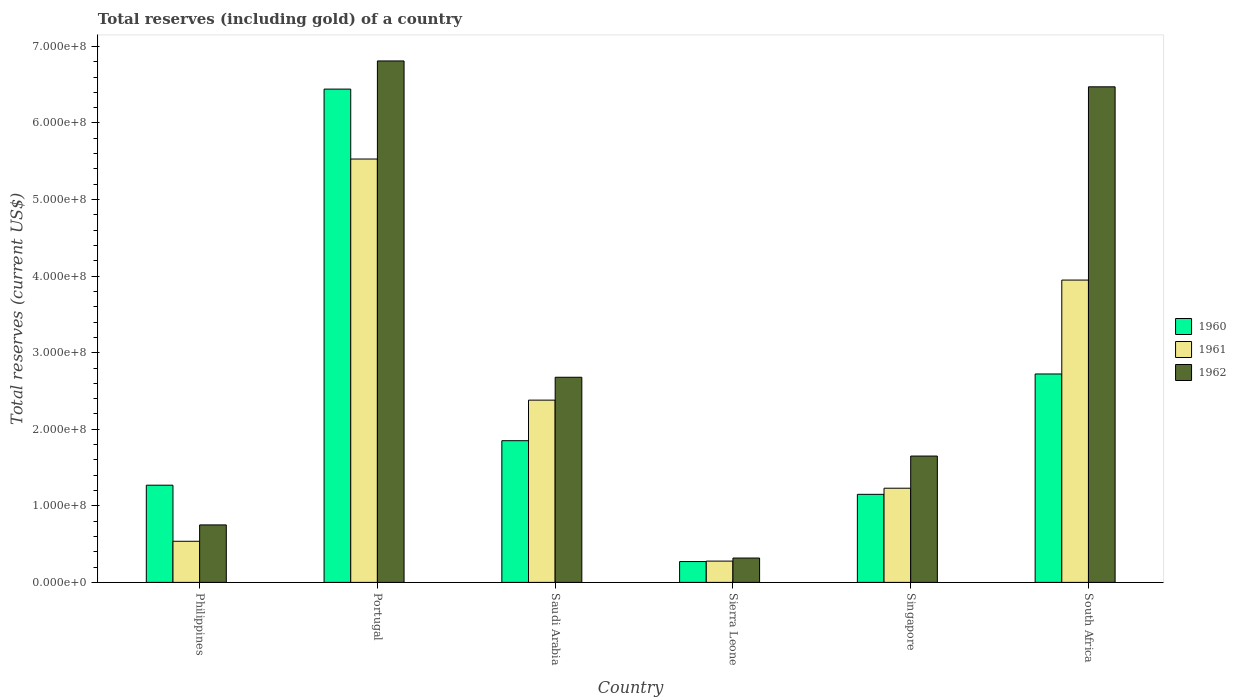How many bars are there on the 5th tick from the left?
Keep it short and to the point. 3. What is the label of the 3rd group of bars from the left?
Give a very brief answer. Saudi Arabia. What is the total reserves (including gold) in 1962 in Saudi Arabia?
Provide a short and direct response. 2.68e+08. Across all countries, what is the maximum total reserves (including gold) in 1960?
Provide a succinct answer. 6.44e+08. Across all countries, what is the minimum total reserves (including gold) in 1962?
Your answer should be very brief. 3.18e+07. In which country was the total reserves (including gold) in 1960 maximum?
Make the answer very short. Portugal. In which country was the total reserves (including gold) in 1961 minimum?
Provide a succinct answer. Sierra Leone. What is the total total reserves (including gold) in 1961 in the graph?
Your answer should be compact. 1.39e+09. What is the difference between the total reserves (including gold) in 1960 in Singapore and that in South Africa?
Offer a terse response. -1.57e+08. What is the difference between the total reserves (including gold) in 1960 in Portugal and the total reserves (including gold) in 1962 in Sierra Leone?
Your response must be concise. 6.12e+08. What is the average total reserves (including gold) in 1961 per country?
Your answer should be compact. 2.32e+08. What is the difference between the total reserves (including gold) of/in 1962 and total reserves (including gold) of/in 1960 in Portugal?
Provide a short and direct response. 3.68e+07. What is the ratio of the total reserves (including gold) in 1962 in Saudi Arabia to that in South Africa?
Provide a short and direct response. 0.41. Is the total reserves (including gold) in 1962 in Philippines less than that in Saudi Arabia?
Offer a terse response. Yes. Is the difference between the total reserves (including gold) in 1962 in Portugal and Saudi Arabia greater than the difference between the total reserves (including gold) in 1960 in Portugal and Saudi Arabia?
Make the answer very short. No. What is the difference between the highest and the second highest total reserves (including gold) in 1961?
Give a very brief answer. -1.58e+08. What is the difference between the highest and the lowest total reserves (including gold) in 1962?
Ensure brevity in your answer.  6.49e+08. What does the 3rd bar from the left in South Africa represents?
Provide a short and direct response. 1962. Is it the case that in every country, the sum of the total reserves (including gold) in 1961 and total reserves (including gold) in 1962 is greater than the total reserves (including gold) in 1960?
Provide a short and direct response. Yes. How many countries are there in the graph?
Your answer should be very brief. 6. Does the graph contain grids?
Offer a terse response. No. Where does the legend appear in the graph?
Keep it short and to the point. Center right. How many legend labels are there?
Your answer should be very brief. 3. How are the legend labels stacked?
Give a very brief answer. Vertical. What is the title of the graph?
Your answer should be very brief. Total reserves (including gold) of a country. What is the label or title of the Y-axis?
Give a very brief answer. Total reserves (current US$). What is the Total reserves (current US$) of 1960 in Philippines?
Offer a terse response. 1.27e+08. What is the Total reserves (current US$) in 1961 in Philippines?
Offer a terse response. 5.37e+07. What is the Total reserves (current US$) in 1962 in Philippines?
Offer a terse response. 7.51e+07. What is the Total reserves (current US$) of 1960 in Portugal?
Provide a short and direct response. 6.44e+08. What is the Total reserves (current US$) in 1961 in Portugal?
Keep it short and to the point. 5.53e+08. What is the Total reserves (current US$) of 1962 in Portugal?
Ensure brevity in your answer.  6.81e+08. What is the Total reserves (current US$) in 1960 in Saudi Arabia?
Your answer should be very brief. 1.85e+08. What is the Total reserves (current US$) in 1961 in Saudi Arabia?
Make the answer very short. 2.38e+08. What is the Total reserves (current US$) in 1962 in Saudi Arabia?
Offer a terse response. 2.68e+08. What is the Total reserves (current US$) of 1960 in Sierra Leone?
Offer a very short reply. 2.72e+07. What is the Total reserves (current US$) of 1961 in Sierra Leone?
Offer a terse response. 2.78e+07. What is the Total reserves (current US$) in 1962 in Sierra Leone?
Your response must be concise. 3.18e+07. What is the Total reserves (current US$) in 1960 in Singapore?
Your answer should be very brief. 1.15e+08. What is the Total reserves (current US$) in 1961 in Singapore?
Offer a terse response. 1.23e+08. What is the Total reserves (current US$) of 1962 in Singapore?
Provide a succinct answer. 1.65e+08. What is the Total reserves (current US$) in 1960 in South Africa?
Give a very brief answer. 2.72e+08. What is the Total reserves (current US$) in 1961 in South Africa?
Your answer should be very brief. 3.95e+08. What is the Total reserves (current US$) of 1962 in South Africa?
Offer a very short reply. 6.47e+08. Across all countries, what is the maximum Total reserves (current US$) in 1960?
Your answer should be very brief. 6.44e+08. Across all countries, what is the maximum Total reserves (current US$) of 1961?
Offer a terse response. 5.53e+08. Across all countries, what is the maximum Total reserves (current US$) of 1962?
Ensure brevity in your answer.  6.81e+08. Across all countries, what is the minimum Total reserves (current US$) of 1960?
Offer a terse response. 2.72e+07. Across all countries, what is the minimum Total reserves (current US$) in 1961?
Offer a terse response. 2.78e+07. Across all countries, what is the minimum Total reserves (current US$) of 1962?
Make the answer very short. 3.18e+07. What is the total Total reserves (current US$) of 1960 in the graph?
Ensure brevity in your answer.  1.37e+09. What is the total Total reserves (current US$) in 1961 in the graph?
Offer a terse response. 1.39e+09. What is the total Total reserves (current US$) in 1962 in the graph?
Ensure brevity in your answer.  1.87e+09. What is the difference between the Total reserves (current US$) in 1960 in Philippines and that in Portugal?
Ensure brevity in your answer.  -5.17e+08. What is the difference between the Total reserves (current US$) of 1961 in Philippines and that in Portugal?
Your answer should be compact. -4.99e+08. What is the difference between the Total reserves (current US$) in 1962 in Philippines and that in Portugal?
Give a very brief answer. -6.06e+08. What is the difference between the Total reserves (current US$) in 1960 in Philippines and that in Saudi Arabia?
Provide a succinct answer. -5.81e+07. What is the difference between the Total reserves (current US$) in 1961 in Philippines and that in Saudi Arabia?
Your answer should be compact. -1.84e+08. What is the difference between the Total reserves (current US$) in 1962 in Philippines and that in Saudi Arabia?
Keep it short and to the point. -1.93e+08. What is the difference between the Total reserves (current US$) in 1960 in Philippines and that in Sierra Leone?
Your response must be concise. 9.97e+07. What is the difference between the Total reserves (current US$) of 1961 in Philippines and that in Sierra Leone?
Make the answer very short. 2.59e+07. What is the difference between the Total reserves (current US$) of 1962 in Philippines and that in Sierra Leone?
Provide a short and direct response. 4.33e+07. What is the difference between the Total reserves (current US$) in 1960 in Philippines and that in Singapore?
Give a very brief answer. 1.19e+07. What is the difference between the Total reserves (current US$) of 1961 in Philippines and that in Singapore?
Offer a terse response. -6.93e+07. What is the difference between the Total reserves (current US$) of 1962 in Philippines and that in Singapore?
Make the answer very short. -8.99e+07. What is the difference between the Total reserves (current US$) in 1960 in Philippines and that in South Africa?
Offer a terse response. -1.45e+08. What is the difference between the Total reserves (current US$) in 1961 in Philippines and that in South Africa?
Keep it short and to the point. -3.41e+08. What is the difference between the Total reserves (current US$) in 1962 in Philippines and that in South Africa?
Your answer should be very brief. -5.72e+08. What is the difference between the Total reserves (current US$) in 1960 in Portugal and that in Saudi Arabia?
Keep it short and to the point. 4.59e+08. What is the difference between the Total reserves (current US$) in 1961 in Portugal and that in Saudi Arabia?
Provide a short and direct response. 3.15e+08. What is the difference between the Total reserves (current US$) of 1962 in Portugal and that in Saudi Arabia?
Provide a succinct answer. 4.13e+08. What is the difference between the Total reserves (current US$) of 1960 in Portugal and that in Sierra Leone?
Provide a succinct answer. 6.17e+08. What is the difference between the Total reserves (current US$) of 1961 in Portugal and that in Sierra Leone?
Keep it short and to the point. 5.25e+08. What is the difference between the Total reserves (current US$) in 1962 in Portugal and that in Sierra Leone?
Make the answer very short. 6.49e+08. What is the difference between the Total reserves (current US$) of 1960 in Portugal and that in Singapore?
Provide a short and direct response. 5.29e+08. What is the difference between the Total reserves (current US$) of 1961 in Portugal and that in Singapore?
Provide a short and direct response. 4.30e+08. What is the difference between the Total reserves (current US$) in 1962 in Portugal and that in Singapore?
Make the answer very short. 5.16e+08. What is the difference between the Total reserves (current US$) of 1960 in Portugal and that in South Africa?
Your response must be concise. 3.72e+08. What is the difference between the Total reserves (current US$) of 1961 in Portugal and that in South Africa?
Offer a very short reply. 1.58e+08. What is the difference between the Total reserves (current US$) of 1962 in Portugal and that in South Africa?
Your answer should be compact. 3.38e+07. What is the difference between the Total reserves (current US$) of 1960 in Saudi Arabia and that in Sierra Leone?
Make the answer very short. 1.58e+08. What is the difference between the Total reserves (current US$) in 1961 in Saudi Arabia and that in Sierra Leone?
Offer a very short reply. 2.10e+08. What is the difference between the Total reserves (current US$) of 1962 in Saudi Arabia and that in Sierra Leone?
Your answer should be compact. 2.36e+08. What is the difference between the Total reserves (current US$) of 1960 in Saudi Arabia and that in Singapore?
Keep it short and to the point. 7.01e+07. What is the difference between the Total reserves (current US$) in 1961 in Saudi Arabia and that in Singapore?
Your answer should be very brief. 1.15e+08. What is the difference between the Total reserves (current US$) in 1962 in Saudi Arabia and that in Singapore?
Keep it short and to the point. 1.03e+08. What is the difference between the Total reserves (current US$) of 1960 in Saudi Arabia and that in South Africa?
Provide a short and direct response. -8.71e+07. What is the difference between the Total reserves (current US$) of 1961 in Saudi Arabia and that in South Africa?
Keep it short and to the point. -1.57e+08. What is the difference between the Total reserves (current US$) in 1962 in Saudi Arabia and that in South Africa?
Your response must be concise. -3.79e+08. What is the difference between the Total reserves (current US$) in 1960 in Sierra Leone and that in Singapore?
Your answer should be compact. -8.78e+07. What is the difference between the Total reserves (current US$) of 1961 in Sierra Leone and that in Singapore?
Offer a terse response. -9.52e+07. What is the difference between the Total reserves (current US$) of 1962 in Sierra Leone and that in Singapore?
Provide a succinct answer. -1.33e+08. What is the difference between the Total reserves (current US$) in 1960 in Sierra Leone and that in South Africa?
Offer a terse response. -2.45e+08. What is the difference between the Total reserves (current US$) of 1961 in Sierra Leone and that in South Africa?
Offer a terse response. -3.67e+08. What is the difference between the Total reserves (current US$) of 1962 in Sierra Leone and that in South Africa?
Your response must be concise. -6.15e+08. What is the difference between the Total reserves (current US$) in 1960 in Singapore and that in South Africa?
Your answer should be compact. -1.57e+08. What is the difference between the Total reserves (current US$) in 1961 in Singapore and that in South Africa?
Ensure brevity in your answer.  -2.72e+08. What is the difference between the Total reserves (current US$) of 1962 in Singapore and that in South Africa?
Ensure brevity in your answer.  -4.82e+08. What is the difference between the Total reserves (current US$) of 1960 in Philippines and the Total reserves (current US$) of 1961 in Portugal?
Keep it short and to the point. -4.26e+08. What is the difference between the Total reserves (current US$) of 1960 in Philippines and the Total reserves (current US$) of 1962 in Portugal?
Offer a terse response. -5.54e+08. What is the difference between the Total reserves (current US$) of 1961 in Philippines and the Total reserves (current US$) of 1962 in Portugal?
Provide a short and direct response. -6.27e+08. What is the difference between the Total reserves (current US$) in 1960 in Philippines and the Total reserves (current US$) in 1961 in Saudi Arabia?
Your answer should be compact. -1.11e+08. What is the difference between the Total reserves (current US$) of 1960 in Philippines and the Total reserves (current US$) of 1962 in Saudi Arabia?
Ensure brevity in your answer.  -1.41e+08. What is the difference between the Total reserves (current US$) of 1961 in Philippines and the Total reserves (current US$) of 1962 in Saudi Arabia?
Offer a terse response. -2.14e+08. What is the difference between the Total reserves (current US$) of 1960 in Philippines and the Total reserves (current US$) of 1961 in Sierra Leone?
Your answer should be compact. 9.91e+07. What is the difference between the Total reserves (current US$) in 1960 in Philippines and the Total reserves (current US$) in 1962 in Sierra Leone?
Give a very brief answer. 9.51e+07. What is the difference between the Total reserves (current US$) in 1961 in Philippines and the Total reserves (current US$) in 1962 in Sierra Leone?
Provide a succinct answer. 2.19e+07. What is the difference between the Total reserves (current US$) of 1960 in Philippines and the Total reserves (current US$) of 1961 in Singapore?
Ensure brevity in your answer.  3.94e+06. What is the difference between the Total reserves (current US$) of 1960 in Philippines and the Total reserves (current US$) of 1962 in Singapore?
Offer a terse response. -3.81e+07. What is the difference between the Total reserves (current US$) in 1961 in Philippines and the Total reserves (current US$) in 1962 in Singapore?
Your answer should be very brief. -1.11e+08. What is the difference between the Total reserves (current US$) in 1960 in Philippines and the Total reserves (current US$) in 1961 in South Africa?
Your response must be concise. -2.68e+08. What is the difference between the Total reserves (current US$) in 1960 in Philippines and the Total reserves (current US$) in 1962 in South Africa?
Ensure brevity in your answer.  -5.20e+08. What is the difference between the Total reserves (current US$) in 1961 in Philippines and the Total reserves (current US$) in 1962 in South Africa?
Provide a short and direct response. -5.94e+08. What is the difference between the Total reserves (current US$) in 1960 in Portugal and the Total reserves (current US$) in 1961 in Saudi Arabia?
Your response must be concise. 4.06e+08. What is the difference between the Total reserves (current US$) in 1960 in Portugal and the Total reserves (current US$) in 1962 in Saudi Arabia?
Ensure brevity in your answer.  3.76e+08. What is the difference between the Total reserves (current US$) of 1961 in Portugal and the Total reserves (current US$) of 1962 in Saudi Arabia?
Make the answer very short. 2.85e+08. What is the difference between the Total reserves (current US$) of 1960 in Portugal and the Total reserves (current US$) of 1961 in Sierra Leone?
Provide a succinct answer. 6.16e+08. What is the difference between the Total reserves (current US$) of 1960 in Portugal and the Total reserves (current US$) of 1962 in Sierra Leone?
Your answer should be compact. 6.12e+08. What is the difference between the Total reserves (current US$) in 1961 in Portugal and the Total reserves (current US$) in 1962 in Sierra Leone?
Offer a very short reply. 5.21e+08. What is the difference between the Total reserves (current US$) of 1960 in Portugal and the Total reserves (current US$) of 1961 in Singapore?
Your answer should be compact. 5.21e+08. What is the difference between the Total reserves (current US$) of 1960 in Portugal and the Total reserves (current US$) of 1962 in Singapore?
Ensure brevity in your answer.  4.79e+08. What is the difference between the Total reserves (current US$) in 1961 in Portugal and the Total reserves (current US$) in 1962 in Singapore?
Your answer should be compact. 3.88e+08. What is the difference between the Total reserves (current US$) of 1960 in Portugal and the Total reserves (current US$) of 1961 in South Africa?
Give a very brief answer. 2.49e+08. What is the difference between the Total reserves (current US$) of 1960 in Portugal and the Total reserves (current US$) of 1962 in South Africa?
Your answer should be very brief. -2.97e+06. What is the difference between the Total reserves (current US$) of 1961 in Portugal and the Total reserves (current US$) of 1962 in South Africa?
Offer a very short reply. -9.43e+07. What is the difference between the Total reserves (current US$) in 1960 in Saudi Arabia and the Total reserves (current US$) in 1961 in Sierra Leone?
Provide a short and direct response. 1.57e+08. What is the difference between the Total reserves (current US$) of 1960 in Saudi Arabia and the Total reserves (current US$) of 1962 in Sierra Leone?
Your answer should be very brief. 1.53e+08. What is the difference between the Total reserves (current US$) in 1961 in Saudi Arabia and the Total reserves (current US$) in 1962 in Sierra Leone?
Ensure brevity in your answer.  2.06e+08. What is the difference between the Total reserves (current US$) of 1960 in Saudi Arabia and the Total reserves (current US$) of 1961 in Singapore?
Ensure brevity in your answer.  6.21e+07. What is the difference between the Total reserves (current US$) in 1960 in Saudi Arabia and the Total reserves (current US$) in 1962 in Singapore?
Offer a terse response. 2.01e+07. What is the difference between the Total reserves (current US$) in 1961 in Saudi Arabia and the Total reserves (current US$) in 1962 in Singapore?
Give a very brief answer. 7.30e+07. What is the difference between the Total reserves (current US$) in 1960 in Saudi Arabia and the Total reserves (current US$) in 1961 in South Africa?
Offer a terse response. -2.10e+08. What is the difference between the Total reserves (current US$) of 1960 in Saudi Arabia and the Total reserves (current US$) of 1962 in South Africa?
Keep it short and to the point. -4.62e+08. What is the difference between the Total reserves (current US$) in 1961 in Saudi Arabia and the Total reserves (current US$) in 1962 in South Africa?
Give a very brief answer. -4.09e+08. What is the difference between the Total reserves (current US$) of 1960 in Sierra Leone and the Total reserves (current US$) of 1961 in Singapore?
Provide a succinct answer. -9.58e+07. What is the difference between the Total reserves (current US$) in 1960 in Sierra Leone and the Total reserves (current US$) in 1962 in Singapore?
Keep it short and to the point. -1.38e+08. What is the difference between the Total reserves (current US$) in 1961 in Sierra Leone and the Total reserves (current US$) in 1962 in Singapore?
Provide a short and direct response. -1.37e+08. What is the difference between the Total reserves (current US$) of 1960 in Sierra Leone and the Total reserves (current US$) of 1961 in South Africa?
Provide a short and direct response. -3.68e+08. What is the difference between the Total reserves (current US$) in 1960 in Sierra Leone and the Total reserves (current US$) in 1962 in South Africa?
Offer a terse response. -6.20e+08. What is the difference between the Total reserves (current US$) in 1961 in Sierra Leone and the Total reserves (current US$) in 1962 in South Africa?
Make the answer very short. -6.19e+08. What is the difference between the Total reserves (current US$) of 1960 in Singapore and the Total reserves (current US$) of 1961 in South Africa?
Your response must be concise. -2.80e+08. What is the difference between the Total reserves (current US$) of 1960 in Singapore and the Total reserves (current US$) of 1962 in South Africa?
Your answer should be very brief. -5.32e+08. What is the difference between the Total reserves (current US$) of 1961 in Singapore and the Total reserves (current US$) of 1962 in South Africa?
Make the answer very short. -5.24e+08. What is the average Total reserves (current US$) in 1960 per country?
Provide a short and direct response. 2.28e+08. What is the average Total reserves (current US$) in 1961 per country?
Your response must be concise. 2.32e+08. What is the average Total reserves (current US$) of 1962 per country?
Provide a short and direct response. 3.11e+08. What is the difference between the Total reserves (current US$) in 1960 and Total reserves (current US$) in 1961 in Philippines?
Give a very brief answer. 7.33e+07. What is the difference between the Total reserves (current US$) in 1960 and Total reserves (current US$) in 1962 in Philippines?
Your answer should be compact. 5.19e+07. What is the difference between the Total reserves (current US$) of 1961 and Total reserves (current US$) of 1962 in Philippines?
Offer a very short reply. -2.14e+07. What is the difference between the Total reserves (current US$) in 1960 and Total reserves (current US$) in 1961 in Portugal?
Offer a terse response. 9.13e+07. What is the difference between the Total reserves (current US$) of 1960 and Total reserves (current US$) of 1962 in Portugal?
Give a very brief answer. -3.68e+07. What is the difference between the Total reserves (current US$) in 1961 and Total reserves (current US$) in 1962 in Portugal?
Provide a succinct answer. -1.28e+08. What is the difference between the Total reserves (current US$) in 1960 and Total reserves (current US$) in 1961 in Saudi Arabia?
Provide a short and direct response. -5.30e+07. What is the difference between the Total reserves (current US$) of 1960 and Total reserves (current US$) of 1962 in Saudi Arabia?
Your answer should be very brief. -8.29e+07. What is the difference between the Total reserves (current US$) in 1961 and Total reserves (current US$) in 1962 in Saudi Arabia?
Your answer should be compact. -2.99e+07. What is the difference between the Total reserves (current US$) of 1960 and Total reserves (current US$) of 1961 in Sierra Leone?
Give a very brief answer. -6.00e+05. What is the difference between the Total reserves (current US$) in 1960 and Total reserves (current US$) in 1962 in Sierra Leone?
Give a very brief answer. -4.60e+06. What is the difference between the Total reserves (current US$) in 1960 and Total reserves (current US$) in 1961 in Singapore?
Make the answer very short. -8.00e+06. What is the difference between the Total reserves (current US$) in 1960 and Total reserves (current US$) in 1962 in Singapore?
Your answer should be very brief. -5.00e+07. What is the difference between the Total reserves (current US$) of 1961 and Total reserves (current US$) of 1962 in Singapore?
Offer a terse response. -4.20e+07. What is the difference between the Total reserves (current US$) of 1960 and Total reserves (current US$) of 1961 in South Africa?
Provide a succinct answer. -1.23e+08. What is the difference between the Total reserves (current US$) in 1960 and Total reserves (current US$) in 1962 in South Africa?
Provide a short and direct response. -3.75e+08. What is the difference between the Total reserves (current US$) in 1961 and Total reserves (current US$) in 1962 in South Africa?
Ensure brevity in your answer.  -2.52e+08. What is the ratio of the Total reserves (current US$) in 1960 in Philippines to that in Portugal?
Your response must be concise. 0.2. What is the ratio of the Total reserves (current US$) in 1961 in Philippines to that in Portugal?
Give a very brief answer. 0.1. What is the ratio of the Total reserves (current US$) in 1962 in Philippines to that in Portugal?
Give a very brief answer. 0.11. What is the ratio of the Total reserves (current US$) in 1960 in Philippines to that in Saudi Arabia?
Your response must be concise. 0.69. What is the ratio of the Total reserves (current US$) of 1961 in Philippines to that in Saudi Arabia?
Your answer should be compact. 0.23. What is the ratio of the Total reserves (current US$) in 1962 in Philippines to that in Saudi Arabia?
Your response must be concise. 0.28. What is the ratio of the Total reserves (current US$) of 1960 in Philippines to that in Sierra Leone?
Ensure brevity in your answer.  4.67. What is the ratio of the Total reserves (current US$) in 1961 in Philippines to that in Sierra Leone?
Give a very brief answer. 1.93. What is the ratio of the Total reserves (current US$) of 1962 in Philippines to that in Sierra Leone?
Your response must be concise. 2.36. What is the ratio of the Total reserves (current US$) of 1960 in Philippines to that in Singapore?
Give a very brief answer. 1.1. What is the ratio of the Total reserves (current US$) in 1961 in Philippines to that in Singapore?
Offer a very short reply. 0.44. What is the ratio of the Total reserves (current US$) of 1962 in Philippines to that in Singapore?
Give a very brief answer. 0.46. What is the ratio of the Total reserves (current US$) in 1960 in Philippines to that in South Africa?
Your response must be concise. 0.47. What is the ratio of the Total reserves (current US$) in 1961 in Philippines to that in South Africa?
Your answer should be very brief. 0.14. What is the ratio of the Total reserves (current US$) of 1962 in Philippines to that in South Africa?
Keep it short and to the point. 0.12. What is the ratio of the Total reserves (current US$) in 1960 in Portugal to that in Saudi Arabia?
Offer a terse response. 3.48. What is the ratio of the Total reserves (current US$) of 1961 in Portugal to that in Saudi Arabia?
Give a very brief answer. 2.32. What is the ratio of the Total reserves (current US$) in 1962 in Portugal to that in Saudi Arabia?
Your response must be concise. 2.54. What is the ratio of the Total reserves (current US$) in 1960 in Portugal to that in Sierra Leone?
Make the answer very short. 23.69. What is the ratio of the Total reserves (current US$) in 1961 in Portugal to that in Sierra Leone?
Keep it short and to the point. 19.89. What is the ratio of the Total reserves (current US$) of 1962 in Portugal to that in Sierra Leone?
Ensure brevity in your answer.  21.42. What is the ratio of the Total reserves (current US$) of 1960 in Portugal to that in Singapore?
Provide a short and direct response. 5.6. What is the ratio of the Total reserves (current US$) of 1961 in Portugal to that in Singapore?
Provide a succinct answer. 4.5. What is the ratio of the Total reserves (current US$) of 1962 in Portugal to that in Singapore?
Your answer should be compact. 4.13. What is the ratio of the Total reserves (current US$) of 1960 in Portugal to that in South Africa?
Your answer should be very brief. 2.37. What is the ratio of the Total reserves (current US$) in 1961 in Portugal to that in South Africa?
Make the answer very short. 1.4. What is the ratio of the Total reserves (current US$) in 1962 in Portugal to that in South Africa?
Your response must be concise. 1.05. What is the ratio of the Total reserves (current US$) in 1960 in Saudi Arabia to that in Sierra Leone?
Your answer should be very brief. 6.8. What is the ratio of the Total reserves (current US$) of 1961 in Saudi Arabia to that in Sierra Leone?
Offer a very short reply. 8.56. What is the ratio of the Total reserves (current US$) in 1962 in Saudi Arabia to that in Sierra Leone?
Make the answer very short. 8.43. What is the ratio of the Total reserves (current US$) of 1960 in Saudi Arabia to that in Singapore?
Give a very brief answer. 1.61. What is the ratio of the Total reserves (current US$) in 1961 in Saudi Arabia to that in Singapore?
Keep it short and to the point. 1.94. What is the ratio of the Total reserves (current US$) in 1962 in Saudi Arabia to that in Singapore?
Offer a very short reply. 1.62. What is the ratio of the Total reserves (current US$) in 1960 in Saudi Arabia to that in South Africa?
Your answer should be compact. 0.68. What is the ratio of the Total reserves (current US$) of 1961 in Saudi Arabia to that in South Africa?
Your response must be concise. 0.6. What is the ratio of the Total reserves (current US$) in 1962 in Saudi Arabia to that in South Africa?
Your answer should be very brief. 0.41. What is the ratio of the Total reserves (current US$) in 1960 in Sierra Leone to that in Singapore?
Provide a short and direct response. 0.24. What is the ratio of the Total reserves (current US$) of 1961 in Sierra Leone to that in Singapore?
Give a very brief answer. 0.23. What is the ratio of the Total reserves (current US$) in 1962 in Sierra Leone to that in Singapore?
Your answer should be very brief. 0.19. What is the ratio of the Total reserves (current US$) of 1960 in Sierra Leone to that in South Africa?
Your answer should be compact. 0.1. What is the ratio of the Total reserves (current US$) of 1961 in Sierra Leone to that in South Africa?
Give a very brief answer. 0.07. What is the ratio of the Total reserves (current US$) of 1962 in Sierra Leone to that in South Africa?
Provide a short and direct response. 0.05. What is the ratio of the Total reserves (current US$) in 1960 in Singapore to that in South Africa?
Ensure brevity in your answer.  0.42. What is the ratio of the Total reserves (current US$) of 1961 in Singapore to that in South Africa?
Offer a very short reply. 0.31. What is the ratio of the Total reserves (current US$) in 1962 in Singapore to that in South Africa?
Offer a terse response. 0.25. What is the difference between the highest and the second highest Total reserves (current US$) in 1960?
Provide a succinct answer. 3.72e+08. What is the difference between the highest and the second highest Total reserves (current US$) of 1961?
Your answer should be very brief. 1.58e+08. What is the difference between the highest and the second highest Total reserves (current US$) in 1962?
Ensure brevity in your answer.  3.38e+07. What is the difference between the highest and the lowest Total reserves (current US$) of 1960?
Give a very brief answer. 6.17e+08. What is the difference between the highest and the lowest Total reserves (current US$) of 1961?
Give a very brief answer. 5.25e+08. What is the difference between the highest and the lowest Total reserves (current US$) of 1962?
Offer a very short reply. 6.49e+08. 